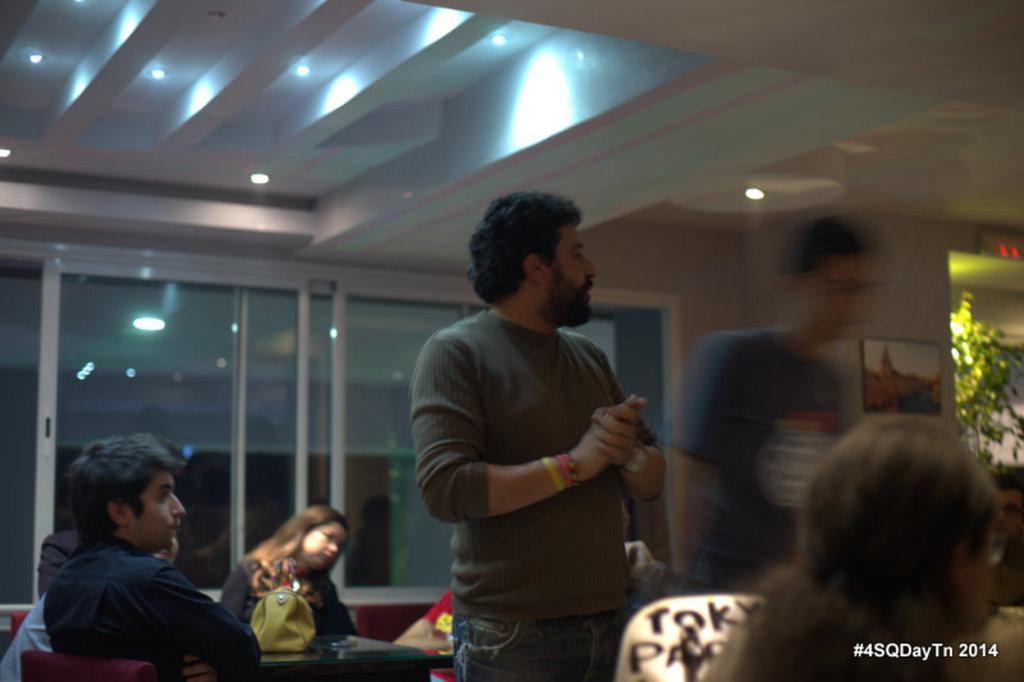Describe this image in one or two sentences. In this picture we can see two men standing, some people sitting on chairs and a table with a bag on it and in the background we can see the lights, windows, plant, frame on the wall. 